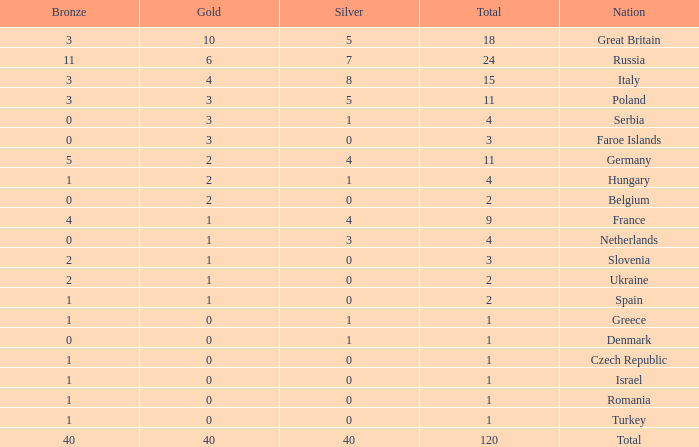What is the average Gold entry for the Netherlands that also has a Bronze entry that is greater than 0? None. 